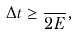Convert formula to latex. <formula><loc_0><loc_0><loc_500><loc_500>\Delta t \geq \frac { } { 2 E } ,</formula> 